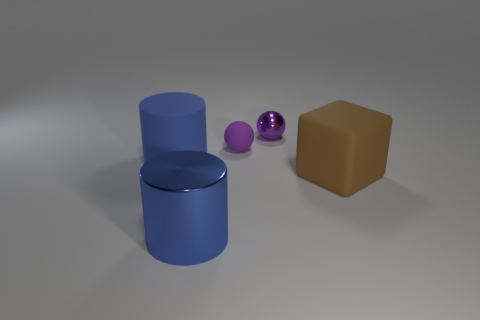Add 4 big blue matte cylinders. How many objects exist? 9 Subtract all cubes. How many objects are left? 4 Subtract 1 cylinders. How many cylinders are left? 1 Subtract all red cubes. Subtract all red cylinders. How many cubes are left? 1 Subtract all small purple blocks. Subtract all small metallic objects. How many objects are left? 4 Add 3 small purple matte spheres. How many small purple matte spheres are left? 4 Add 2 purple things. How many purple things exist? 4 Subtract 0 green balls. How many objects are left? 5 